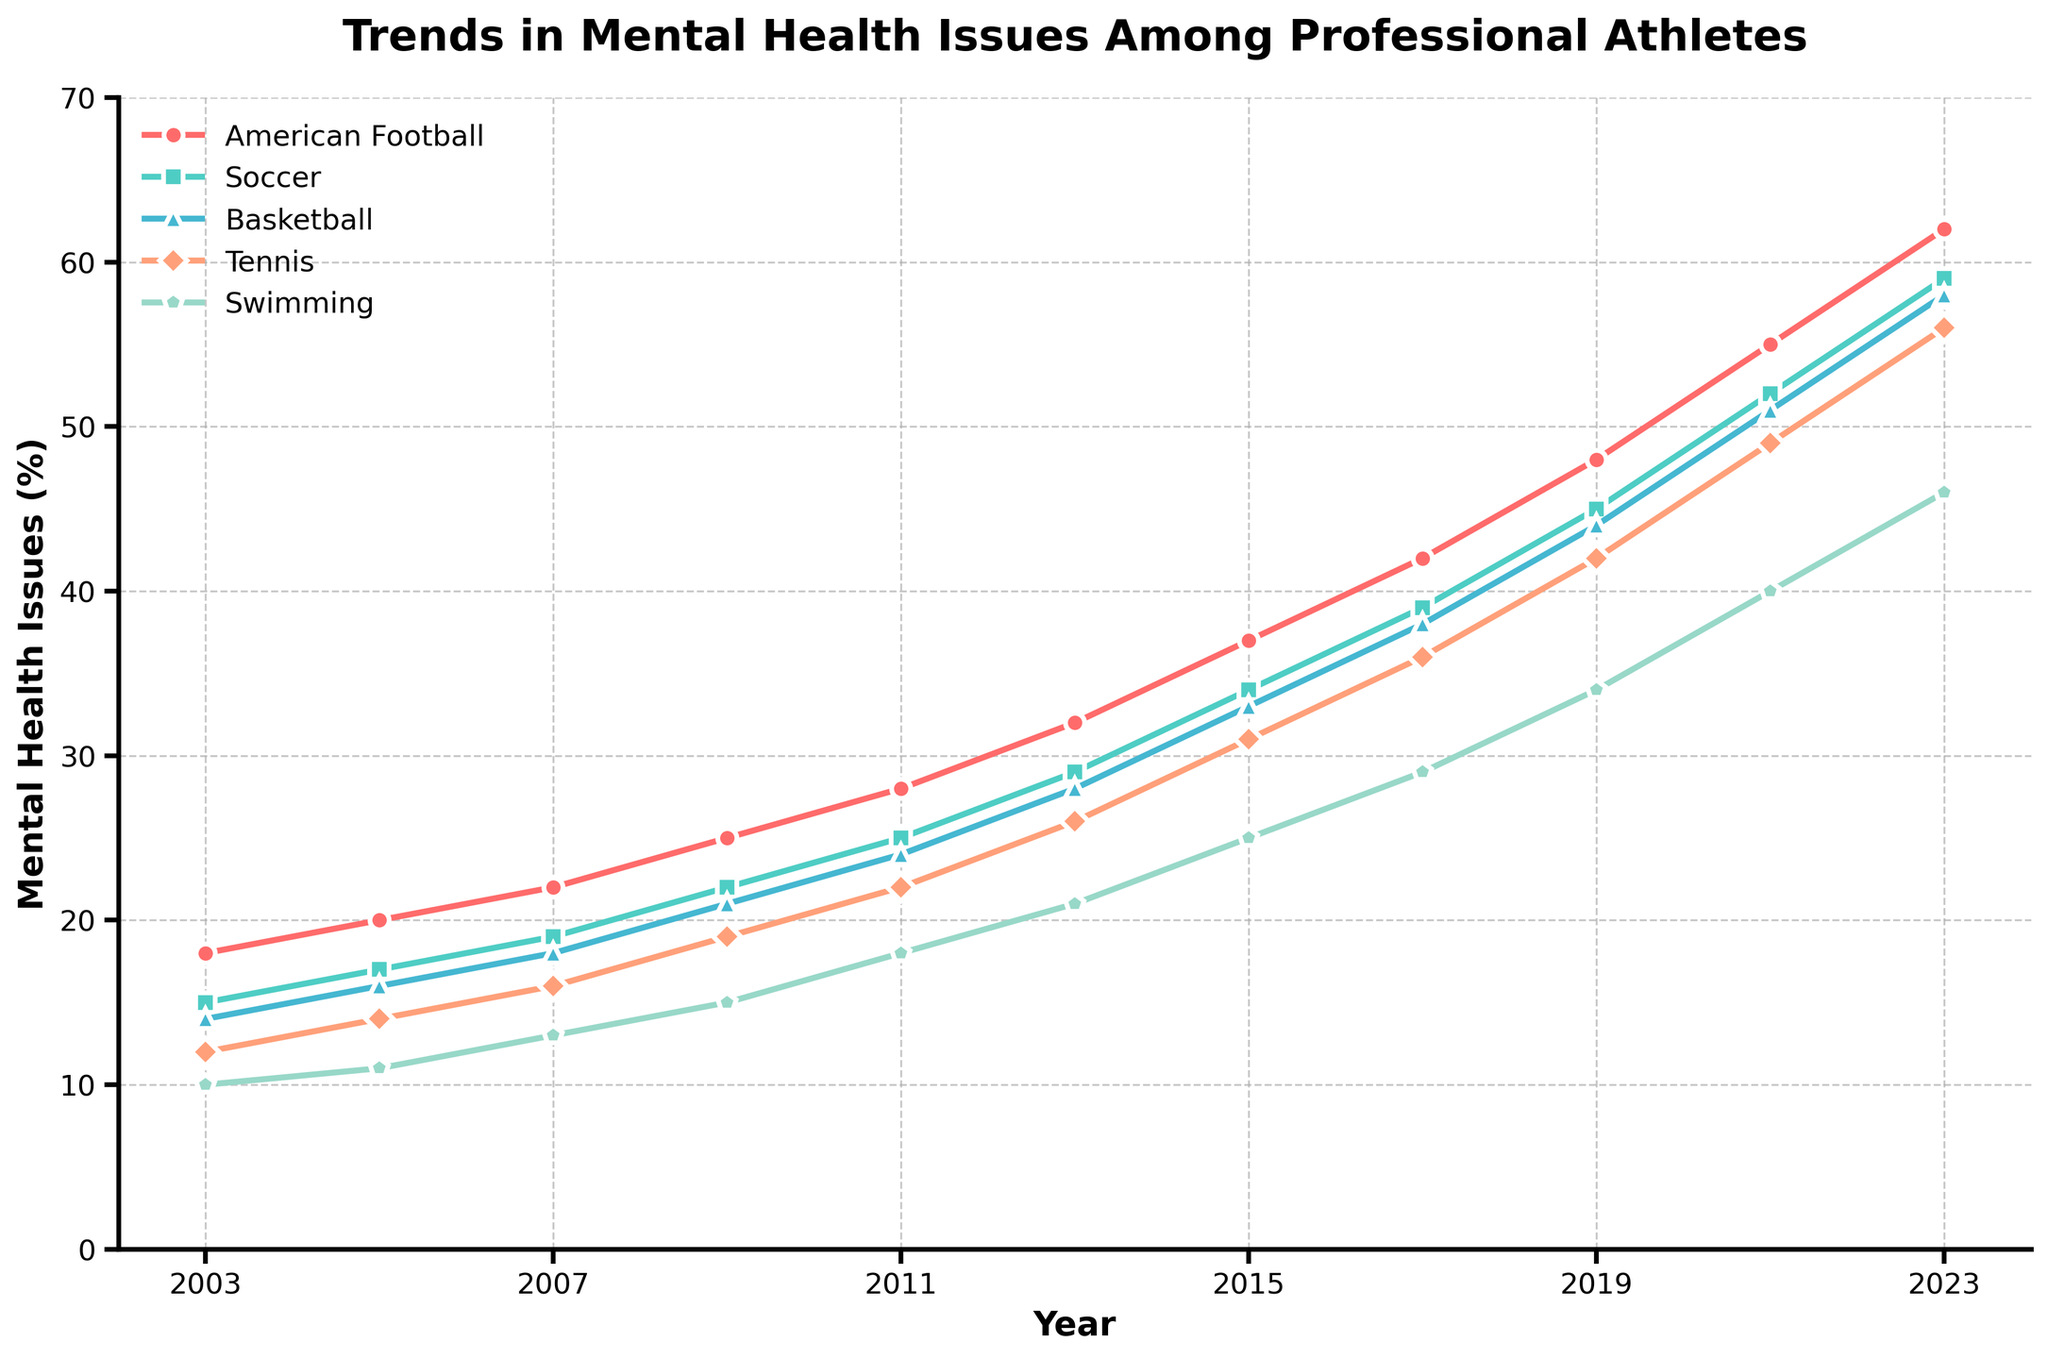What is the overall trend in mental health issues among professional athletes over the past two decades? The overall trend shows a clear and consistent increase in the percentage of mental health issues among professional athletes from 2003 to 2023 across all sports.
Answer: Increasing Which sport showed the highest percentage of mental health issues in 2023? By looking at the values for the year 2023, American Football has the highest percentage of mental health issues at 62%.
Answer: American Football How much did the percentage of mental health issues in Swimming increase from 2003 to 2023? In 2003, Swimming had a rate of 10%, and in 2023, it had a rate of 46%. The increase is 46% - 10% = 36%.
Answer: 36% Compare the trends of American Football and Tennis; in which year does American Football surpass the 50% mark and Tennis surpass the 40% mark? American Football surpasses 50% in the year 2021, as it reaches 55%. Tennis surpasses 40% in the same year, 2021, where it reaches 49%.
Answer: 2021 What is the difference in the percentage of mental health issues between Soccer and Basketball in 2017? In 2017, Soccer has a rate of 39% while Basketball has a rate of 38%. The difference is 39% - 38% = 1%.
Answer: 1% Which sport has the steepest increase in mental health issues over the years? By observing the slopes of the lines in the chart, American Football has the steepest increase, showing a dramatic rise from 18% in 2003 to 62% in 2023.
Answer: American Football Between which years did Tennis see the largest increase in mental health issues? By examining the values, Tennis saw the largest increase between 2019 and 2021, rising from 42% to 49%, a difference of 7%.
Answer: 2019-2021 What is the average percentage increase in mental health issues for Soccer over each year? The percentage for Soccer starts at 15% in 2003 and ends at 59% in 2023. The increase is 59% - 15% = 44%, over 20 years. Thus, the average increase per year is 44% / 20 ≈ 2.2%.
Answer: 2.2% In 2015, which sports had mental health issue rates above 30%? In 2015, American Football has 37%, Soccer has 34%, and Basketball has 33%, all above 30%. Tennis at 31% also qualifies, while Swimming at 25% does not.
Answer: American Football, Soccer, Basketball, Tennis 